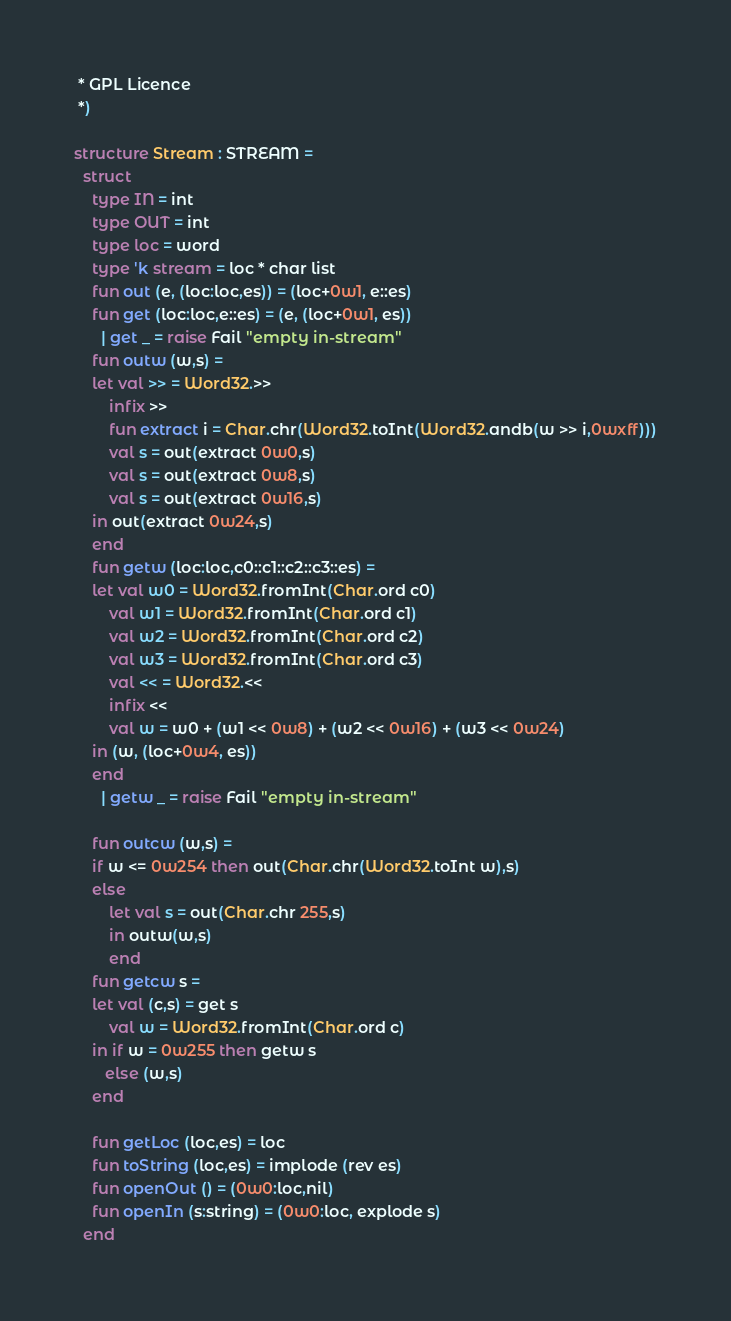<code> <loc_0><loc_0><loc_500><loc_500><_SML_> * GPL Licence
 *)

structure Stream : STREAM =
  struct
    type IN = int
    type OUT = int
    type loc = word
    type 'k stream = loc * char list
    fun out (e, (loc:loc,es)) = (loc+0w1, e::es)
    fun get (loc:loc,e::es) = (e, (loc+0w1, es))
      | get _ = raise Fail "empty in-stream"
    fun outw (w,s) =
	let val >> = Word32.>>
	    infix >>
	    fun extract i = Char.chr(Word32.toInt(Word32.andb(w >> i,0wxff)))
	    val s = out(extract 0w0,s)
	    val s = out(extract 0w8,s)
	    val s = out(extract 0w16,s)
	in out(extract 0w24,s)
	end
    fun getw (loc:loc,c0::c1::c2::c3::es) = 
	let val w0 = Word32.fromInt(Char.ord c0)
	    val w1 = Word32.fromInt(Char.ord c1)
	    val w2 = Word32.fromInt(Char.ord c2)
	    val w3 = Word32.fromInt(Char.ord c3)
	    val << = Word32.<<
	    infix <<
	    val w = w0 + (w1 << 0w8) + (w2 << 0w16) + (w3 << 0w24) 
	in (w, (loc+0w4, es))
	end
      | getw _ = raise Fail "empty in-stream"

    fun outcw (w,s) =
	if w <= 0w254 then out(Char.chr(Word32.toInt w),s)
	else 
	    let val s = out(Char.chr 255,s)
	    in outw(w,s)
	    end
    fun getcw s =
	let val (c,s) = get s
	    val w = Word32.fromInt(Char.ord c)
	in if w = 0w255 then getw s
	   else (w,s)
	end

    fun getLoc (loc,es) = loc
    fun toString (loc,es) = implode (rev es)
    fun openOut () = (0w0:loc,nil)
    fun openIn (s:string) = (0w0:loc, explode s)
  end
</code> 